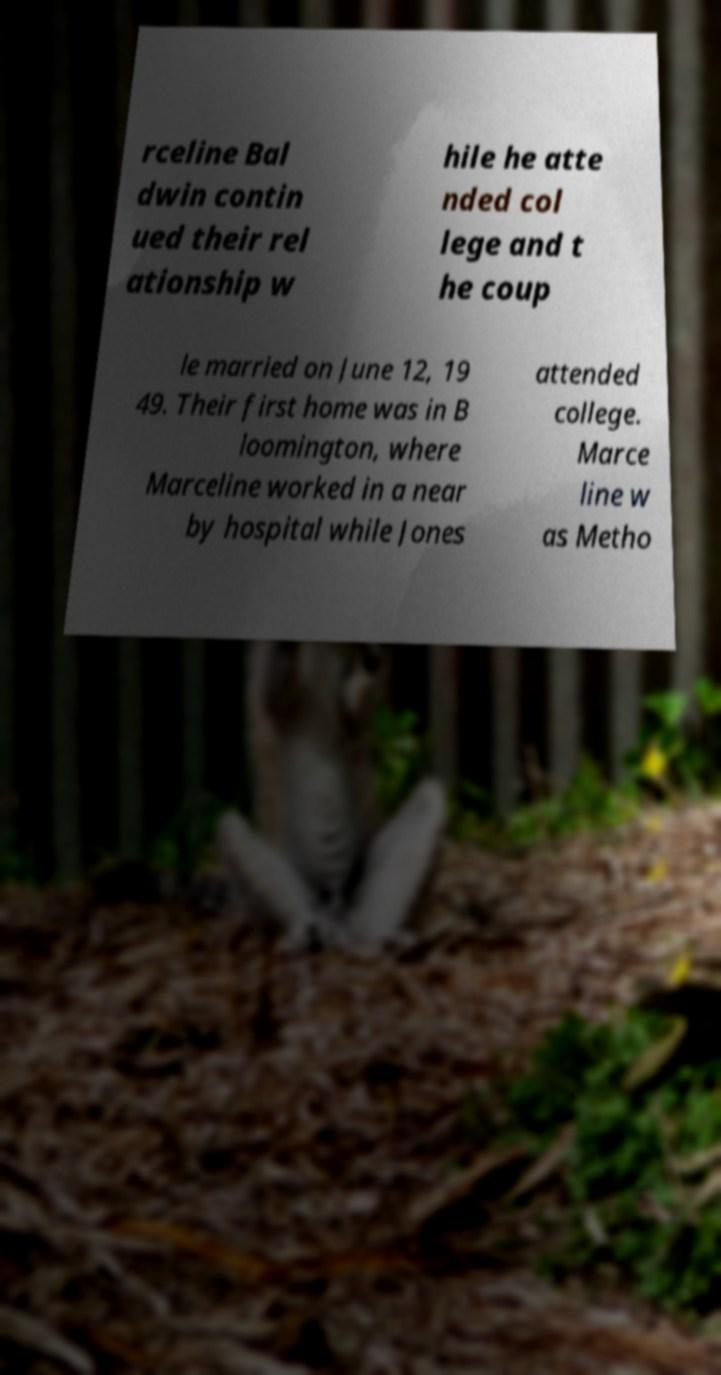For documentation purposes, I need the text within this image transcribed. Could you provide that? rceline Bal dwin contin ued their rel ationship w hile he atte nded col lege and t he coup le married on June 12, 19 49. Their first home was in B loomington, where Marceline worked in a near by hospital while Jones attended college. Marce line w as Metho 